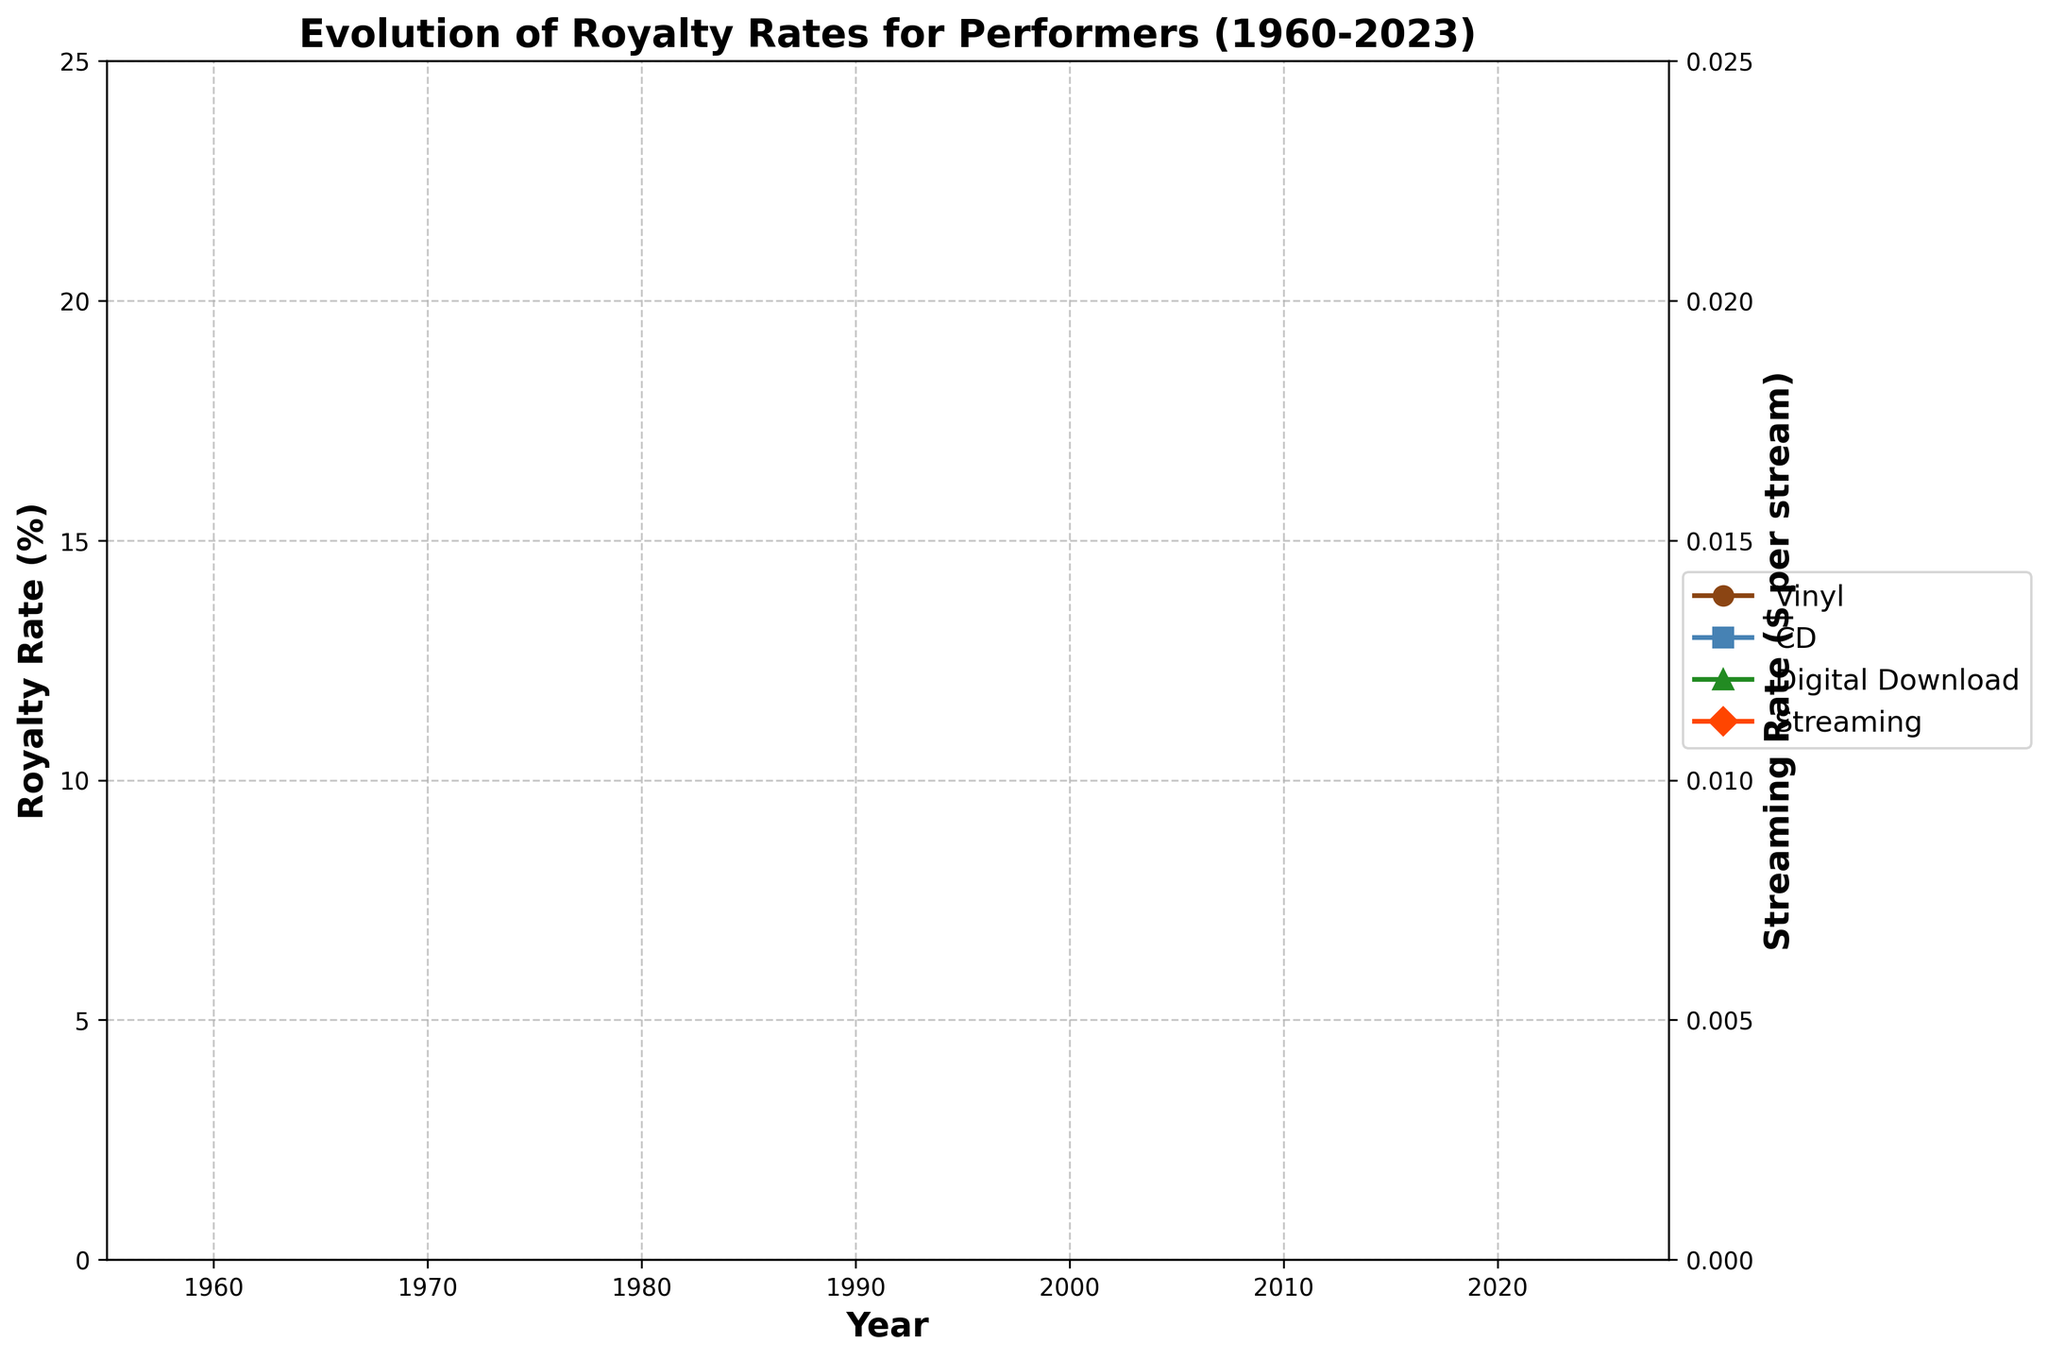What is the overall trend of the royalty rate for vinyl from 1960 to 2023? The royalty rate for vinyl shows an overall increasing trend from 2.5% in 1960 to 7.0% in 2023. This trend is consistently upward.
Answer: Increasing trend How does the royalty rate for CDs in 1990 compare to the rate for vinyl in the same year? In the year 1990, the royalty rate for CDs is 10%, while for vinyl it is 4%. Hence, the royalty rate for CDs is higher than that of vinyl.
Answer: CD rate is higher Which media format had the highest royalty rate in 2023? By visually inspecting the endpoints of each line, it is clear that the CD format has the highest royalty rate in 2023 at 17%.
Answer: CD By how much did the royalty rate for digital downloads increase from 2000 to 2023? The royalty rate for digital downloads increased from 15% in 2000 to 24% in 2023. The increase is calculated as 24% - 15%, which equals 9%.
Answer: 9% What is the difference in royalty rates between vinyl and streaming in 2023? In 2023, the royalty rate for vinyl is 7% and for streaming is $0.008 per stream. The streaming rate can be interpreted as 0.8% (since it's multiplied by 100 to match the percentage format). So, the difference is 7% - 0.8%, which equals 6.2%.
Answer: 6.2% Which media format had the slowest rate of increase in royalty rates over the given period? By looking at the slopes of the lines representing each format, streaming shows the slowest rate of increase since it starts from $0.003 in 2010 to $0.008 in 2023.
Answer: Streaming During which decade did vinyl experience the highest rate of increase in royalty rates? By observing the changes in the slope of the line representing vinyl, the highest rate of increase is seen from 1980 to 1990 where it moves from 3.5% to 4%, a difference of 0.5%.
Answer: 1980-1990 What is the average royalty rate for CDs from 1990 to 2023? The rates for CDs from 1990 to 2023 are 10%, 12%, 13%, 14%, 15%, 16%, and 17%. The sum of these values is 97%. The average is calculated as 97% divided by 7, which equals 13.86%.
Answer: 13.86% In 2020, how much higher is the royalty rate for digital downloads compared to streaming? In 2020, the royalty rate for digital downloads is 23%, while for streaming it is $0.007 per stream (equivalent to 0.7% when expressed in percentage terms). The difference is calculated as 23% - 0.7%, which equals 22.3%.
Answer: 22.3% How many times higher is the vinyl royalty rate in 2023 compared to 1960? The vinyl royalty rate in 2023 is 7% and in 1960 it was 2.5%. The ratio is calculated as 7 / 2.5, which equals 2.8 times.
Answer: 2.8 times 